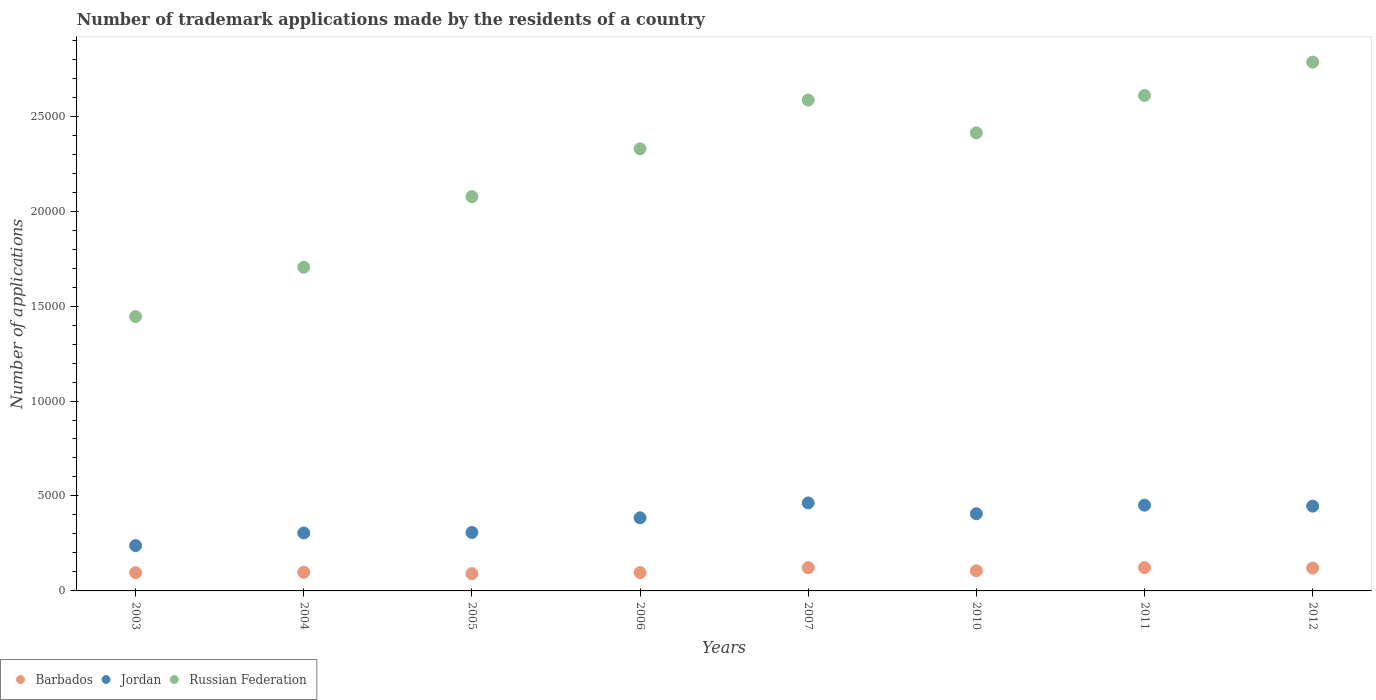How many different coloured dotlines are there?
Your answer should be compact. 3. What is the number of trademark applications made by the residents in Russian Federation in 2011?
Give a very brief answer. 2.61e+04. Across all years, what is the maximum number of trademark applications made by the residents in Jordan?
Keep it short and to the point. 4633. Across all years, what is the minimum number of trademark applications made by the residents in Jordan?
Give a very brief answer. 2386. In which year was the number of trademark applications made by the residents in Jordan maximum?
Keep it short and to the point. 2007. What is the total number of trademark applications made by the residents in Jordan in the graph?
Offer a very short reply. 3.00e+04. What is the difference between the number of trademark applications made by the residents in Barbados in 2006 and that in 2007?
Provide a short and direct response. -257. What is the difference between the number of trademark applications made by the residents in Barbados in 2006 and the number of trademark applications made by the residents in Russian Federation in 2004?
Keep it short and to the point. -1.61e+04. What is the average number of trademark applications made by the residents in Barbados per year?
Your answer should be very brief. 1066.38. In the year 2012, what is the difference between the number of trademark applications made by the residents in Barbados and number of trademark applications made by the residents in Russian Federation?
Your answer should be compact. -2.66e+04. What is the ratio of the number of trademark applications made by the residents in Jordan in 2003 to that in 2007?
Give a very brief answer. 0.52. Is the number of trademark applications made by the residents in Jordan in 2006 less than that in 2011?
Give a very brief answer. Yes. Is the difference between the number of trademark applications made by the residents in Barbados in 2005 and 2006 greater than the difference between the number of trademark applications made by the residents in Russian Federation in 2005 and 2006?
Your answer should be compact. Yes. What is the difference between the highest and the second highest number of trademark applications made by the residents in Jordan?
Ensure brevity in your answer.  119. What is the difference between the highest and the lowest number of trademark applications made by the residents in Jordan?
Your response must be concise. 2247. Is the sum of the number of trademark applications made by the residents in Russian Federation in 2007 and 2011 greater than the maximum number of trademark applications made by the residents in Barbados across all years?
Make the answer very short. Yes. Does the number of trademark applications made by the residents in Barbados monotonically increase over the years?
Offer a very short reply. No. Is the number of trademark applications made by the residents in Barbados strictly greater than the number of trademark applications made by the residents in Russian Federation over the years?
Offer a very short reply. No. Is the number of trademark applications made by the residents in Russian Federation strictly less than the number of trademark applications made by the residents in Barbados over the years?
Provide a short and direct response. No. What is the difference between two consecutive major ticks on the Y-axis?
Provide a short and direct response. 5000. Are the values on the major ticks of Y-axis written in scientific E-notation?
Keep it short and to the point. No. Does the graph contain any zero values?
Make the answer very short. No. Where does the legend appear in the graph?
Your response must be concise. Bottom left. How many legend labels are there?
Give a very brief answer. 3. How are the legend labels stacked?
Give a very brief answer. Horizontal. What is the title of the graph?
Give a very brief answer. Number of trademark applications made by the residents of a country. Does "Antigua and Barbuda" appear as one of the legend labels in the graph?
Ensure brevity in your answer.  No. What is the label or title of the X-axis?
Ensure brevity in your answer.  Years. What is the label or title of the Y-axis?
Offer a very short reply. Number of applications. What is the Number of applications in Barbados in 2003?
Offer a terse response. 960. What is the Number of applications in Jordan in 2003?
Give a very brief answer. 2386. What is the Number of applications in Russian Federation in 2003?
Your answer should be very brief. 1.44e+04. What is the Number of applications in Barbados in 2004?
Provide a succinct answer. 981. What is the Number of applications of Jordan in 2004?
Ensure brevity in your answer.  3051. What is the Number of applications of Russian Federation in 2004?
Keep it short and to the point. 1.70e+04. What is the Number of applications in Barbados in 2005?
Make the answer very short. 909. What is the Number of applications of Jordan in 2005?
Make the answer very short. 3078. What is the Number of applications in Russian Federation in 2005?
Offer a very short reply. 2.08e+04. What is the Number of applications of Barbados in 2006?
Make the answer very short. 966. What is the Number of applications in Jordan in 2006?
Ensure brevity in your answer.  3850. What is the Number of applications in Russian Federation in 2006?
Provide a short and direct response. 2.33e+04. What is the Number of applications of Barbados in 2007?
Your response must be concise. 1223. What is the Number of applications in Jordan in 2007?
Offer a very short reply. 4633. What is the Number of applications in Russian Federation in 2007?
Your answer should be very brief. 2.58e+04. What is the Number of applications in Barbados in 2010?
Give a very brief answer. 1061. What is the Number of applications in Jordan in 2010?
Ensure brevity in your answer.  4064. What is the Number of applications of Russian Federation in 2010?
Offer a terse response. 2.41e+04. What is the Number of applications of Barbados in 2011?
Keep it short and to the point. 1229. What is the Number of applications of Jordan in 2011?
Provide a succinct answer. 4514. What is the Number of applications in Russian Federation in 2011?
Give a very brief answer. 2.61e+04. What is the Number of applications of Barbados in 2012?
Offer a very short reply. 1202. What is the Number of applications in Jordan in 2012?
Provide a short and direct response. 4465. What is the Number of applications in Russian Federation in 2012?
Make the answer very short. 2.78e+04. Across all years, what is the maximum Number of applications of Barbados?
Make the answer very short. 1229. Across all years, what is the maximum Number of applications in Jordan?
Ensure brevity in your answer.  4633. Across all years, what is the maximum Number of applications of Russian Federation?
Provide a short and direct response. 2.78e+04. Across all years, what is the minimum Number of applications in Barbados?
Offer a terse response. 909. Across all years, what is the minimum Number of applications of Jordan?
Your response must be concise. 2386. Across all years, what is the minimum Number of applications of Russian Federation?
Offer a very short reply. 1.44e+04. What is the total Number of applications of Barbados in the graph?
Make the answer very short. 8531. What is the total Number of applications of Jordan in the graph?
Make the answer very short. 3.00e+04. What is the total Number of applications in Russian Federation in the graph?
Your answer should be very brief. 1.79e+05. What is the difference between the Number of applications of Jordan in 2003 and that in 2004?
Give a very brief answer. -665. What is the difference between the Number of applications of Russian Federation in 2003 and that in 2004?
Your response must be concise. -2593. What is the difference between the Number of applications of Barbados in 2003 and that in 2005?
Your answer should be compact. 51. What is the difference between the Number of applications in Jordan in 2003 and that in 2005?
Give a very brief answer. -692. What is the difference between the Number of applications in Russian Federation in 2003 and that in 2005?
Offer a terse response. -6315. What is the difference between the Number of applications in Jordan in 2003 and that in 2006?
Keep it short and to the point. -1464. What is the difference between the Number of applications in Russian Federation in 2003 and that in 2006?
Your response must be concise. -8831. What is the difference between the Number of applications of Barbados in 2003 and that in 2007?
Ensure brevity in your answer.  -263. What is the difference between the Number of applications in Jordan in 2003 and that in 2007?
Provide a short and direct response. -2247. What is the difference between the Number of applications in Russian Federation in 2003 and that in 2007?
Ensure brevity in your answer.  -1.14e+04. What is the difference between the Number of applications in Barbados in 2003 and that in 2010?
Ensure brevity in your answer.  -101. What is the difference between the Number of applications in Jordan in 2003 and that in 2010?
Keep it short and to the point. -1678. What is the difference between the Number of applications in Russian Federation in 2003 and that in 2010?
Provide a succinct answer. -9674. What is the difference between the Number of applications of Barbados in 2003 and that in 2011?
Offer a very short reply. -269. What is the difference between the Number of applications in Jordan in 2003 and that in 2011?
Offer a terse response. -2128. What is the difference between the Number of applications in Russian Federation in 2003 and that in 2011?
Offer a terse response. -1.16e+04. What is the difference between the Number of applications of Barbados in 2003 and that in 2012?
Your answer should be compact. -242. What is the difference between the Number of applications in Jordan in 2003 and that in 2012?
Your response must be concise. -2079. What is the difference between the Number of applications of Russian Federation in 2003 and that in 2012?
Ensure brevity in your answer.  -1.34e+04. What is the difference between the Number of applications of Russian Federation in 2004 and that in 2005?
Provide a succinct answer. -3722. What is the difference between the Number of applications in Jordan in 2004 and that in 2006?
Your answer should be compact. -799. What is the difference between the Number of applications of Russian Federation in 2004 and that in 2006?
Your answer should be compact. -6238. What is the difference between the Number of applications of Barbados in 2004 and that in 2007?
Your answer should be compact. -242. What is the difference between the Number of applications of Jordan in 2004 and that in 2007?
Provide a succinct answer. -1582. What is the difference between the Number of applications in Russian Federation in 2004 and that in 2007?
Ensure brevity in your answer.  -8804. What is the difference between the Number of applications in Barbados in 2004 and that in 2010?
Offer a terse response. -80. What is the difference between the Number of applications of Jordan in 2004 and that in 2010?
Your answer should be very brief. -1013. What is the difference between the Number of applications of Russian Federation in 2004 and that in 2010?
Your answer should be very brief. -7081. What is the difference between the Number of applications in Barbados in 2004 and that in 2011?
Ensure brevity in your answer.  -248. What is the difference between the Number of applications of Jordan in 2004 and that in 2011?
Give a very brief answer. -1463. What is the difference between the Number of applications in Russian Federation in 2004 and that in 2011?
Give a very brief answer. -9049. What is the difference between the Number of applications of Barbados in 2004 and that in 2012?
Your answer should be very brief. -221. What is the difference between the Number of applications of Jordan in 2004 and that in 2012?
Provide a succinct answer. -1414. What is the difference between the Number of applications of Russian Federation in 2004 and that in 2012?
Ensure brevity in your answer.  -1.08e+04. What is the difference between the Number of applications in Barbados in 2005 and that in 2006?
Ensure brevity in your answer.  -57. What is the difference between the Number of applications of Jordan in 2005 and that in 2006?
Give a very brief answer. -772. What is the difference between the Number of applications in Russian Federation in 2005 and that in 2006?
Ensure brevity in your answer.  -2516. What is the difference between the Number of applications of Barbados in 2005 and that in 2007?
Your answer should be compact. -314. What is the difference between the Number of applications in Jordan in 2005 and that in 2007?
Provide a succinct answer. -1555. What is the difference between the Number of applications of Russian Federation in 2005 and that in 2007?
Your response must be concise. -5082. What is the difference between the Number of applications of Barbados in 2005 and that in 2010?
Your answer should be very brief. -152. What is the difference between the Number of applications of Jordan in 2005 and that in 2010?
Make the answer very short. -986. What is the difference between the Number of applications of Russian Federation in 2005 and that in 2010?
Offer a very short reply. -3359. What is the difference between the Number of applications of Barbados in 2005 and that in 2011?
Make the answer very short. -320. What is the difference between the Number of applications in Jordan in 2005 and that in 2011?
Provide a succinct answer. -1436. What is the difference between the Number of applications in Russian Federation in 2005 and that in 2011?
Your answer should be very brief. -5327. What is the difference between the Number of applications in Barbados in 2005 and that in 2012?
Your response must be concise. -293. What is the difference between the Number of applications in Jordan in 2005 and that in 2012?
Your response must be concise. -1387. What is the difference between the Number of applications in Russian Federation in 2005 and that in 2012?
Your answer should be compact. -7081. What is the difference between the Number of applications in Barbados in 2006 and that in 2007?
Offer a terse response. -257. What is the difference between the Number of applications in Jordan in 2006 and that in 2007?
Give a very brief answer. -783. What is the difference between the Number of applications of Russian Federation in 2006 and that in 2007?
Provide a short and direct response. -2566. What is the difference between the Number of applications of Barbados in 2006 and that in 2010?
Provide a succinct answer. -95. What is the difference between the Number of applications in Jordan in 2006 and that in 2010?
Your answer should be compact. -214. What is the difference between the Number of applications in Russian Federation in 2006 and that in 2010?
Offer a very short reply. -843. What is the difference between the Number of applications of Barbados in 2006 and that in 2011?
Your answer should be very brief. -263. What is the difference between the Number of applications of Jordan in 2006 and that in 2011?
Offer a terse response. -664. What is the difference between the Number of applications in Russian Federation in 2006 and that in 2011?
Provide a short and direct response. -2811. What is the difference between the Number of applications of Barbados in 2006 and that in 2012?
Keep it short and to the point. -236. What is the difference between the Number of applications in Jordan in 2006 and that in 2012?
Your answer should be very brief. -615. What is the difference between the Number of applications of Russian Federation in 2006 and that in 2012?
Your answer should be compact. -4565. What is the difference between the Number of applications in Barbados in 2007 and that in 2010?
Your response must be concise. 162. What is the difference between the Number of applications of Jordan in 2007 and that in 2010?
Offer a very short reply. 569. What is the difference between the Number of applications in Russian Federation in 2007 and that in 2010?
Keep it short and to the point. 1723. What is the difference between the Number of applications of Barbados in 2007 and that in 2011?
Your answer should be very brief. -6. What is the difference between the Number of applications of Jordan in 2007 and that in 2011?
Provide a succinct answer. 119. What is the difference between the Number of applications of Russian Federation in 2007 and that in 2011?
Keep it short and to the point. -245. What is the difference between the Number of applications of Barbados in 2007 and that in 2012?
Offer a very short reply. 21. What is the difference between the Number of applications in Jordan in 2007 and that in 2012?
Make the answer very short. 168. What is the difference between the Number of applications of Russian Federation in 2007 and that in 2012?
Provide a short and direct response. -1999. What is the difference between the Number of applications of Barbados in 2010 and that in 2011?
Your answer should be very brief. -168. What is the difference between the Number of applications in Jordan in 2010 and that in 2011?
Offer a very short reply. -450. What is the difference between the Number of applications in Russian Federation in 2010 and that in 2011?
Offer a very short reply. -1968. What is the difference between the Number of applications in Barbados in 2010 and that in 2012?
Give a very brief answer. -141. What is the difference between the Number of applications in Jordan in 2010 and that in 2012?
Your answer should be compact. -401. What is the difference between the Number of applications in Russian Federation in 2010 and that in 2012?
Give a very brief answer. -3722. What is the difference between the Number of applications in Barbados in 2011 and that in 2012?
Provide a succinct answer. 27. What is the difference between the Number of applications of Jordan in 2011 and that in 2012?
Offer a terse response. 49. What is the difference between the Number of applications in Russian Federation in 2011 and that in 2012?
Your answer should be compact. -1754. What is the difference between the Number of applications in Barbados in 2003 and the Number of applications in Jordan in 2004?
Make the answer very short. -2091. What is the difference between the Number of applications in Barbados in 2003 and the Number of applications in Russian Federation in 2004?
Your response must be concise. -1.61e+04. What is the difference between the Number of applications of Jordan in 2003 and the Number of applications of Russian Federation in 2004?
Your answer should be compact. -1.47e+04. What is the difference between the Number of applications of Barbados in 2003 and the Number of applications of Jordan in 2005?
Make the answer very short. -2118. What is the difference between the Number of applications in Barbados in 2003 and the Number of applications in Russian Federation in 2005?
Your answer should be compact. -1.98e+04. What is the difference between the Number of applications of Jordan in 2003 and the Number of applications of Russian Federation in 2005?
Keep it short and to the point. -1.84e+04. What is the difference between the Number of applications in Barbados in 2003 and the Number of applications in Jordan in 2006?
Your answer should be compact. -2890. What is the difference between the Number of applications in Barbados in 2003 and the Number of applications in Russian Federation in 2006?
Your response must be concise. -2.23e+04. What is the difference between the Number of applications in Jordan in 2003 and the Number of applications in Russian Federation in 2006?
Keep it short and to the point. -2.09e+04. What is the difference between the Number of applications in Barbados in 2003 and the Number of applications in Jordan in 2007?
Offer a very short reply. -3673. What is the difference between the Number of applications in Barbados in 2003 and the Number of applications in Russian Federation in 2007?
Offer a very short reply. -2.49e+04. What is the difference between the Number of applications of Jordan in 2003 and the Number of applications of Russian Federation in 2007?
Keep it short and to the point. -2.35e+04. What is the difference between the Number of applications in Barbados in 2003 and the Number of applications in Jordan in 2010?
Make the answer very short. -3104. What is the difference between the Number of applications in Barbados in 2003 and the Number of applications in Russian Federation in 2010?
Your response must be concise. -2.32e+04. What is the difference between the Number of applications of Jordan in 2003 and the Number of applications of Russian Federation in 2010?
Ensure brevity in your answer.  -2.17e+04. What is the difference between the Number of applications in Barbados in 2003 and the Number of applications in Jordan in 2011?
Offer a terse response. -3554. What is the difference between the Number of applications of Barbados in 2003 and the Number of applications of Russian Federation in 2011?
Your response must be concise. -2.51e+04. What is the difference between the Number of applications of Jordan in 2003 and the Number of applications of Russian Federation in 2011?
Provide a short and direct response. -2.37e+04. What is the difference between the Number of applications in Barbados in 2003 and the Number of applications in Jordan in 2012?
Offer a very short reply. -3505. What is the difference between the Number of applications of Barbados in 2003 and the Number of applications of Russian Federation in 2012?
Offer a terse response. -2.69e+04. What is the difference between the Number of applications of Jordan in 2003 and the Number of applications of Russian Federation in 2012?
Your answer should be compact. -2.55e+04. What is the difference between the Number of applications of Barbados in 2004 and the Number of applications of Jordan in 2005?
Provide a succinct answer. -2097. What is the difference between the Number of applications in Barbados in 2004 and the Number of applications in Russian Federation in 2005?
Make the answer very short. -1.98e+04. What is the difference between the Number of applications of Jordan in 2004 and the Number of applications of Russian Federation in 2005?
Your answer should be very brief. -1.77e+04. What is the difference between the Number of applications in Barbados in 2004 and the Number of applications in Jordan in 2006?
Your answer should be very brief. -2869. What is the difference between the Number of applications of Barbados in 2004 and the Number of applications of Russian Federation in 2006?
Your answer should be very brief. -2.23e+04. What is the difference between the Number of applications in Jordan in 2004 and the Number of applications in Russian Federation in 2006?
Offer a very short reply. -2.02e+04. What is the difference between the Number of applications of Barbados in 2004 and the Number of applications of Jordan in 2007?
Your response must be concise. -3652. What is the difference between the Number of applications in Barbados in 2004 and the Number of applications in Russian Federation in 2007?
Ensure brevity in your answer.  -2.49e+04. What is the difference between the Number of applications in Jordan in 2004 and the Number of applications in Russian Federation in 2007?
Provide a succinct answer. -2.28e+04. What is the difference between the Number of applications of Barbados in 2004 and the Number of applications of Jordan in 2010?
Provide a short and direct response. -3083. What is the difference between the Number of applications of Barbados in 2004 and the Number of applications of Russian Federation in 2010?
Your answer should be compact. -2.31e+04. What is the difference between the Number of applications of Jordan in 2004 and the Number of applications of Russian Federation in 2010?
Give a very brief answer. -2.11e+04. What is the difference between the Number of applications in Barbados in 2004 and the Number of applications in Jordan in 2011?
Provide a short and direct response. -3533. What is the difference between the Number of applications in Barbados in 2004 and the Number of applications in Russian Federation in 2011?
Offer a terse response. -2.51e+04. What is the difference between the Number of applications of Jordan in 2004 and the Number of applications of Russian Federation in 2011?
Make the answer very short. -2.30e+04. What is the difference between the Number of applications of Barbados in 2004 and the Number of applications of Jordan in 2012?
Your answer should be very brief. -3484. What is the difference between the Number of applications in Barbados in 2004 and the Number of applications in Russian Federation in 2012?
Provide a short and direct response. -2.69e+04. What is the difference between the Number of applications in Jordan in 2004 and the Number of applications in Russian Federation in 2012?
Give a very brief answer. -2.48e+04. What is the difference between the Number of applications in Barbados in 2005 and the Number of applications in Jordan in 2006?
Offer a terse response. -2941. What is the difference between the Number of applications of Barbados in 2005 and the Number of applications of Russian Federation in 2006?
Keep it short and to the point. -2.24e+04. What is the difference between the Number of applications in Jordan in 2005 and the Number of applications in Russian Federation in 2006?
Provide a succinct answer. -2.02e+04. What is the difference between the Number of applications in Barbados in 2005 and the Number of applications in Jordan in 2007?
Offer a very short reply. -3724. What is the difference between the Number of applications of Barbados in 2005 and the Number of applications of Russian Federation in 2007?
Keep it short and to the point. -2.49e+04. What is the difference between the Number of applications in Jordan in 2005 and the Number of applications in Russian Federation in 2007?
Your response must be concise. -2.28e+04. What is the difference between the Number of applications in Barbados in 2005 and the Number of applications in Jordan in 2010?
Provide a short and direct response. -3155. What is the difference between the Number of applications of Barbados in 2005 and the Number of applications of Russian Federation in 2010?
Your response must be concise. -2.32e+04. What is the difference between the Number of applications of Jordan in 2005 and the Number of applications of Russian Federation in 2010?
Your response must be concise. -2.10e+04. What is the difference between the Number of applications of Barbados in 2005 and the Number of applications of Jordan in 2011?
Ensure brevity in your answer.  -3605. What is the difference between the Number of applications of Barbados in 2005 and the Number of applications of Russian Federation in 2011?
Offer a terse response. -2.52e+04. What is the difference between the Number of applications in Jordan in 2005 and the Number of applications in Russian Federation in 2011?
Your response must be concise. -2.30e+04. What is the difference between the Number of applications in Barbados in 2005 and the Number of applications in Jordan in 2012?
Offer a very short reply. -3556. What is the difference between the Number of applications of Barbados in 2005 and the Number of applications of Russian Federation in 2012?
Provide a short and direct response. -2.69e+04. What is the difference between the Number of applications in Jordan in 2005 and the Number of applications in Russian Federation in 2012?
Ensure brevity in your answer.  -2.48e+04. What is the difference between the Number of applications in Barbados in 2006 and the Number of applications in Jordan in 2007?
Make the answer very short. -3667. What is the difference between the Number of applications of Barbados in 2006 and the Number of applications of Russian Federation in 2007?
Provide a succinct answer. -2.49e+04. What is the difference between the Number of applications of Jordan in 2006 and the Number of applications of Russian Federation in 2007?
Offer a very short reply. -2.20e+04. What is the difference between the Number of applications of Barbados in 2006 and the Number of applications of Jordan in 2010?
Give a very brief answer. -3098. What is the difference between the Number of applications of Barbados in 2006 and the Number of applications of Russian Federation in 2010?
Your response must be concise. -2.32e+04. What is the difference between the Number of applications of Jordan in 2006 and the Number of applications of Russian Federation in 2010?
Offer a very short reply. -2.03e+04. What is the difference between the Number of applications of Barbados in 2006 and the Number of applications of Jordan in 2011?
Ensure brevity in your answer.  -3548. What is the difference between the Number of applications of Barbados in 2006 and the Number of applications of Russian Federation in 2011?
Make the answer very short. -2.51e+04. What is the difference between the Number of applications of Jordan in 2006 and the Number of applications of Russian Federation in 2011?
Give a very brief answer. -2.22e+04. What is the difference between the Number of applications in Barbados in 2006 and the Number of applications in Jordan in 2012?
Your answer should be very brief. -3499. What is the difference between the Number of applications of Barbados in 2006 and the Number of applications of Russian Federation in 2012?
Give a very brief answer. -2.69e+04. What is the difference between the Number of applications in Jordan in 2006 and the Number of applications in Russian Federation in 2012?
Keep it short and to the point. -2.40e+04. What is the difference between the Number of applications in Barbados in 2007 and the Number of applications in Jordan in 2010?
Your answer should be compact. -2841. What is the difference between the Number of applications in Barbados in 2007 and the Number of applications in Russian Federation in 2010?
Offer a very short reply. -2.29e+04. What is the difference between the Number of applications of Jordan in 2007 and the Number of applications of Russian Federation in 2010?
Your answer should be very brief. -1.95e+04. What is the difference between the Number of applications of Barbados in 2007 and the Number of applications of Jordan in 2011?
Give a very brief answer. -3291. What is the difference between the Number of applications in Barbados in 2007 and the Number of applications in Russian Federation in 2011?
Ensure brevity in your answer.  -2.49e+04. What is the difference between the Number of applications of Jordan in 2007 and the Number of applications of Russian Federation in 2011?
Provide a short and direct response. -2.15e+04. What is the difference between the Number of applications of Barbados in 2007 and the Number of applications of Jordan in 2012?
Offer a terse response. -3242. What is the difference between the Number of applications of Barbados in 2007 and the Number of applications of Russian Federation in 2012?
Your response must be concise. -2.66e+04. What is the difference between the Number of applications of Jordan in 2007 and the Number of applications of Russian Federation in 2012?
Provide a short and direct response. -2.32e+04. What is the difference between the Number of applications in Barbados in 2010 and the Number of applications in Jordan in 2011?
Your answer should be very brief. -3453. What is the difference between the Number of applications of Barbados in 2010 and the Number of applications of Russian Federation in 2011?
Provide a succinct answer. -2.50e+04. What is the difference between the Number of applications in Jordan in 2010 and the Number of applications in Russian Federation in 2011?
Keep it short and to the point. -2.20e+04. What is the difference between the Number of applications of Barbados in 2010 and the Number of applications of Jordan in 2012?
Keep it short and to the point. -3404. What is the difference between the Number of applications of Barbados in 2010 and the Number of applications of Russian Federation in 2012?
Your answer should be very brief. -2.68e+04. What is the difference between the Number of applications in Jordan in 2010 and the Number of applications in Russian Federation in 2012?
Make the answer very short. -2.38e+04. What is the difference between the Number of applications in Barbados in 2011 and the Number of applications in Jordan in 2012?
Keep it short and to the point. -3236. What is the difference between the Number of applications in Barbados in 2011 and the Number of applications in Russian Federation in 2012?
Your answer should be very brief. -2.66e+04. What is the difference between the Number of applications of Jordan in 2011 and the Number of applications of Russian Federation in 2012?
Your response must be concise. -2.33e+04. What is the average Number of applications of Barbados per year?
Your answer should be compact. 1066.38. What is the average Number of applications in Jordan per year?
Your response must be concise. 3755.12. What is the average Number of applications of Russian Federation per year?
Provide a short and direct response. 2.24e+04. In the year 2003, what is the difference between the Number of applications in Barbados and Number of applications in Jordan?
Your answer should be very brief. -1426. In the year 2003, what is the difference between the Number of applications in Barbados and Number of applications in Russian Federation?
Provide a succinct answer. -1.35e+04. In the year 2003, what is the difference between the Number of applications of Jordan and Number of applications of Russian Federation?
Keep it short and to the point. -1.21e+04. In the year 2004, what is the difference between the Number of applications in Barbados and Number of applications in Jordan?
Ensure brevity in your answer.  -2070. In the year 2004, what is the difference between the Number of applications of Barbados and Number of applications of Russian Federation?
Make the answer very short. -1.61e+04. In the year 2004, what is the difference between the Number of applications of Jordan and Number of applications of Russian Federation?
Provide a succinct answer. -1.40e+04. In the year 2005, what is the difference between the Number of applications in Barbados and Number of applications in Jordan?
Offer a very short reply. -2169. In the year 2005, what is the difference between the Number of applications in Barbados and Number of applications in Russian Federation?
Your answer should be compact. -1.99e+04. In the year 2005, what is the difference between the Number of applications of Jordan and Number of applications of Russian Federation?
Ensure brevity in your answer.  -1.77e+04. In the year 2006, what is the difference between the Number of applications in Barbados and Number of applications in Jordan?
Your answer should be very brief. -2884. In the year 2006, what is the difference between the Number of applications of Barbados and Number of applications of Russian Federation?
Give a very brief answer. -2.23e+04. In the year 2006, what is the difference between the Number of applications of Jordan and Number of applications of Russian Federation?
Ensure brevity in your answer.  -1.94e+04. In the year 2007, what is the difference between the Number of applications of Barbados and Number of applications of Jordan?
Provide a succinct answer. -3410. In the year 2007, what is the difference between the Number of applications in Barbados and Number of applications in Russian Federation?
Provide a succinct answer. -2.46e+04. In the year 2007, what is the difference between the Number of applications of Jordan and Number of applications of Russian Federation?
Your answer should be very brief. -2.12e+04. In the year 2010, what is the difference between the Number of applications of Barbados and Number of applications of Jordan?
Provide a short and direct response. -3003. In the year 2010, what is the difference between the Number of applications of Barbados and Number of applications of Russian Federation?
Your answer should be compact. -2.31e+04. In the year 2010, what is the difference between the Number of applications in Jordan and Number of applications in Russian Federation?
Ensure brevity in your answer.  -2.01e+04. In the year 2011, what is the difference between the Number of applications of Barbados and Number of applications of Jordan?
Your answer should be compact. -3285. In the year 2011, what is the difference between the Number of applications of Barbados and Number of applications of Russian Federation?
Give a very brief answer. -2.49e+04. In the year 2011, what is the difference between the Number of applications of Jordan and Number of applications of Russian Federation?
Offer a terse response. -2.16e+04. In the year 2012, what is the difference between the Number of applications of Barbados and Number of applications of Jordan?
Make the answer very short. -3263. In the year 2012, what is the difference between the Number of applications of Barbados and Number of applications of Russian Federation?
Your response must be concise. -2.66e+04. In the year 2012, what is the difference between the Number of applications in Jordan and Number of applications in Russian Federation?
Offer a terse response. -2.34e+04. What is the ratio of the Number of applications of Barbados in 2003 to that in 2004?
Keep it short and to the point. 0.98. What is the ratio of the Number of applications in Jordan in 2003 to that in 2004?
Your response must be concise. 0.78. What is the ratio of the Number of applications in Russian Federation in 2003 to that in 2004?
Offer a terse response. 0.85. What is the ratio of the Number of applications in Barbados in 2003 to that in 2005?
Provide a short and direct response. 1.06. What is the ratio of the Number of applications in Jordan in 2003 to that in 2005?
Offer a very short reply. 0.78. What is the ratio of the Number of applications of Russian Federation in 2003 to that in 2005?
Your answer should be very brief. 0.7. What is the ratio of the Number of applications in Jordan in 2003 to that in 2006?
Your answer should be very brief. 0.62. What is the ratio of the Number of applications of Russian Federation in 2003 to that in 2006?
Give a very brief answer. 0.62. What is the ratio of the Number of applications in Barbados in 2003 to that in 2007?
Offer a terse response. 0.79. What is the ratio of the Number of applications in Jordan in 2003 to that in 2007?
Your response must be concise. 0.52. What is the ratio of the Number of applications in Russian Federation in 2003 to that in 2007?
Your answer should be very brief. 0.56. What is the ratio of the Number of applications in Barbados in 2003 to that in 2010?
Your answer should be very brief. 0.9. What is the ratio of the Number of applications of Jordan in 2003 to that in 2010?
Offer a very short reply. 0.59. What is the ratio of the Number of applications of Russian Federation in 2003 to that in 2010?
Your answer should be compact. 0.6. What is the ratio of the Number of applications of Barbados in 2003 to that in 2011?
Offer a terse response. 0.78. What is the ratio of the Number of applications in Jordan in 2003 to that in 2011?
Your answer should be very brief. 0.53. What is the ratio of the Number of applications of Russian Federation in 2003 to that in 2011?
Your answer should be compact. 0.55. What is the ratio of the Number of applications in Barbados in 2003 to that in 2012?
Provide a short and direct response. 0.8. What is the ratio of the Number of applications of Jordan in 2003 to that in 2012?
Your response must be concise. 0.53. What is the ratio of the Number of applications in Russian Federation in 2003 to that in 2012?
Give a very brief answer. 0.52. What is the ratio of the Number of applications in Barbados in 2004 to that in 2005?
Your answer should be compact. 1.08. What is the ratio of the Number of applications of Russian Federation in 2004 to that in 2005?
Ensure brevity in your answer.  0.82. What is the ratio of the Number of applications of Barbados in 2004 to that in 2006?
Your response must be concise. 1.02. What is the ratio of the Number of applications in Jordan in 2004 to that in 2006?
Ensure brevity in your answer.  0.79. What is the ratio of the Number of applications in Russian Federation in 2004 to that in 2006?
Your answer should be very brief. 0.73. What is the ratio of the Number of applications of Barbados in 2004 to that in 2007?
Ensure brevity in your answer.  0.8. What is the ratio of the Number of applications of Jordan in 2004 to that in 2007?
Provide a succinct answer. 0.66. What is the ratio of the Number of applications of Russian Federation in 2004 to that in 2007?
Offer a very short reply. 0.66. What is the ratio of the Number of applications of Barbados in 2004 to that in 2010?
Provide a short and direct response. 0.92. What is the ratio of the Number of applications in Jordan in 2004 to that in 2010?
Your answer should be very brief. 0.75. What is the ratio of the Number of applications in Russian Federation in 2004 to that in 2010?
Your answer should be very brief. 0.71. What is the ratio of the Number of applications of Barbados in 2004 to that in 2011?
Offer a terse response. 0.8. What is the ratio of the Number of applications of Jordan in 2004 to that in 2011?
Make the answer very short. 0.68. What is the ratio of the Number of applications in Russian Federation in 2004 to that in 2011?
Offer a very short reply. 0.65. What is the ratio of the Number of applications in Barbados in 2004 to that in 2012?
Offer a terse response. 0.82. What is the ratio of the Number of applications of Jordan in 2004 to that in 2012?
Your answer should be compact. 0.68. What is the ratio of the Number of applications in Russian Federation in 2004 to that in 2012?
Give a very brief answer. 0.61. What is the ratio of the Number of applications of Barbados in 2005 to that in 2006?
Ensure brevity in your answer.  0.94. What is the ratio of the Number of applications of Jordan in 2005 to that in 2006?
Give a very brief answer. 0.8. What is the ratio of the Number of applications in Russian Federation in 2005 to that in 2006?
Provide a succinct answer. 0.89. What is the ratio of the Number of applications of Barbados in 2005 to that in 2007?
Provide a short and direct response. 0.74. What is the ratio of the Number of applications of Jordan in 2005 to that in 2007?
Ensure brevity in your answer.  0.66. What is the ratio of the Number of applications in Russian Federation in 2005 to that in 2007?
Your response must be concise. 0.8. What is the ratio of the Number of applications of Barbados in 2005 to that in 2010?
Give a very brief answer. 0.86. What is the ratio of the Number of applications of Jordan in 2005 to that in 2010?
Provide a succinct answer. 0.76. What is the ratio of the Number of applications of Russian Federation in 2005 to that in 2010?
Provide a short and direct response. 0.86. What is the ratio of the Number of applications of Barbados in 2005 to that in 2011?
Offer a terse response. 0.74. What is the ratio of the Number of applications in Jordan in 2005 to that in 2011?
Give a very brief answer. 0.68. What is the ratio of the Number of applications of Russian Federation in 2005 to that in 2011?
Your answer should be compact. 0.8. What is the ratio of the Number of applications of Barbados in 2005 to that in 2012?
Keep it short and to the point. 0.76. What is the ratio of the Number of applications of Jordan in 2005 to that in 2012?
Ensure brevity in your answer.  0.69. What is the ratio of the Number of applications in Russian Federation in 2005 to that in 2012?
Keep it short and to the point. 0.75. What is the ratio of the Number of applications in Barbados in 2006 to that in 2007?
Offer a very short reply. 0.79. What is the ratio of the Number of applications in Jordan in 2006 to that in 2007?
Your answer should be compact. 0.83. What is the ratio of the Number of applications of Russian Federation in 2006 to that in 2007?
Your answer should be compact. 0.9. What is the ratio of the Number of applications in Barbados in 2006 to that in 2010?
Provide a succinct answer. 0.91. What is the ratio of the Number of applications in Jordan in 2006 to that in 2010?
Provide a short and direct response. 0.95. What is the ratio of the Number of applications in Russian Federation in 2006 to that in 2010?
Your response must be concise. 0.97. What is the ratio of the Number of applications in Barbados in 2006 to that in 2011?
Offer a very short reply. 0.79. What is the ratio of the Number of applications of Jordan in 2006 to that in 2011?
Make the answer very short. 0.85. What is the ratio of the Number of applications of Russian Federation in 2006 to that in 2011?
Make the answer very short. 0.89. What is the ratio of the Number of applications of Barbados in 2006 to that in 2012?
Give a very brief answer. 0.8. What is the ratio of the Number of applications of Jordan in 2006 to that in 2012?
Offer a very short reply. 0.86. What is the ratio of the Number of applications of Russian Federation in 2006 to that in 2012?
Keep it short and to the point. 0.84. What is the ratio of the Number of applications of Barbados in 2007 to that in 2010?
Make the answer very short. 1.15. What is the ratio of the Number of applications of Jordan in 2007 to that in 2010?
Offer a terse response. 1.14. What is the ratio of the Number of applications in Russian Federation in 2007 to that in 2010?
Your response must be concise. 1.07. What is the ratio of the Number of applications in Barbados in 2007 to that in 2011?
Give a very brief answer. 1. What is the ratio of the Number of applications in Jordan in 2007 to that in 2011?
Provide a succinct answer. 1.03. What is the ratio of the Number of applications in Russian Federation in 2007 to that in 2011?
Your answer should be very brief. 0.99. What is the ratio of the Number of applications of Barbados in 2007 to that in 2012?
Offer a terse response. 1.02. What is the ratio of the Number of applications of Jordan in 2007 to that in 2012?
Your response must be concise. 1.04. What is the ratio of the Number of applications in Russian Federation in 2007 to that in 2012?
Ensure brevity in your answer.  0.93. What is the ratio of the Number of applications of Barbados in 2010 to that in 2011?
Offer a very short reply. 0.86. What is the ratio of the Number of applications in Jordan in 2010 to that in 2011?
Offer a terse response. 0.9. What is the ratio of the Number of applications in Russian Federation in 2010 to that in 2011?
Make the answer very short. 0.92. What is the ratio of the Number of applications in Barbados in 2010 to that in 2012?
Make the answer very short. 0.88. What is the ratio of the Number of applications of Jordan in 2010 to that in 2012?
Offer a terse response. 0.91. What is the ratio of the Number of applications in Russian Federation in 2010 to that in 2012?
Offer a terse response. 0.87. What is the ratio of the Number of applications of Barbados in 2011 to that in 2012?
Your answer should be very brief. 1.02. What is the ratio of the Number of applications in Jordan in 2011 to that in 2012?
Offer a terse response. 1.01. What is the ratio of the Number of applications of Russian Federation in 2011 to that in 2012?
Your answer should be very brief. 0.94. What is the difference between the highest and the second highest Number of applications of Jordan?
Your response must be concise. 119. What is the difference between the highest and the second highest Number of applications in Russian Federation?
Your answer should be compact. 1754. What is the difference between the highest and the lowest Number of applications in Barbados?
Your response must be concise. 320. What is the difference between the highest and the lowest Number of applications of Jordan?
Provide a short and direct response. 2247. What is the difference between the highest and the lowest Number of applications of Russian Federation?
Offer a terse response. 1.34e+04. 